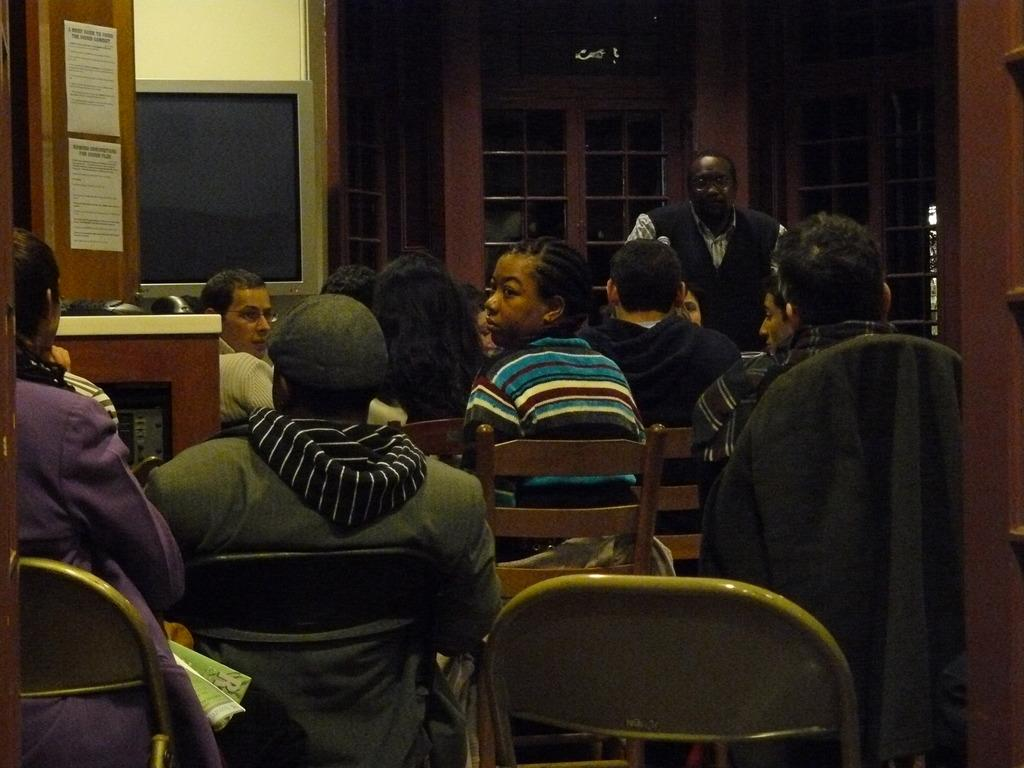What are the people in the image doing? The people in the image are sitting in chairs. Is there anyone standing in the image? Yes, there is a person standing in the middle of the image. What can be seen in the top left corner of the image? There are papers pasted in the top left corner of the image. What is the father's opinion about the writing on the papers in the image? There is no information about a father or any writing on the papers in the image, so it is not possible to determine the father's opinion. 